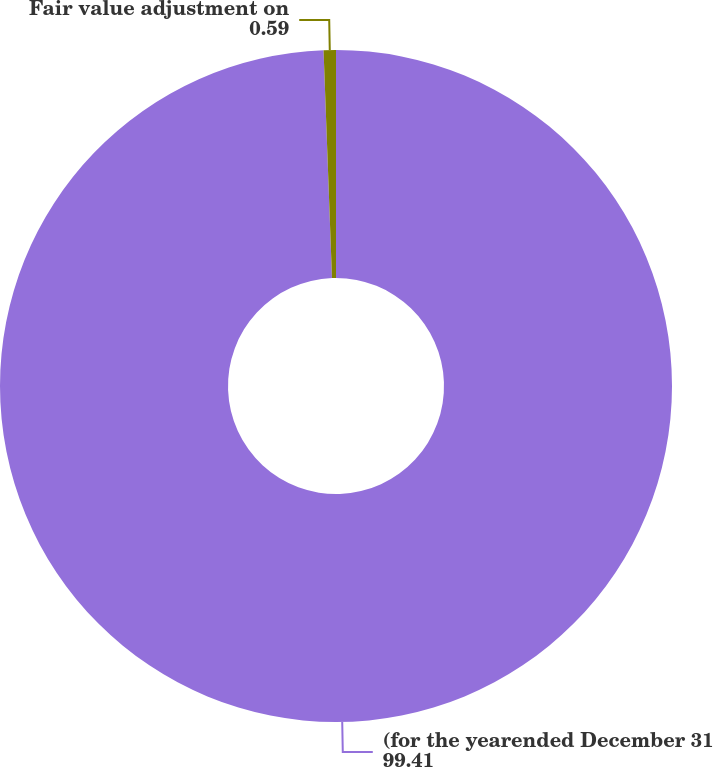Convert chart. <chart><loc_0><loc_0><loc_500><loc_500><pie_chart><fcel>(for the yearended December 31<fcel>Fair value adjustment on<nl><fcel>99.41%<fcel>0.59%<nl></chart> 